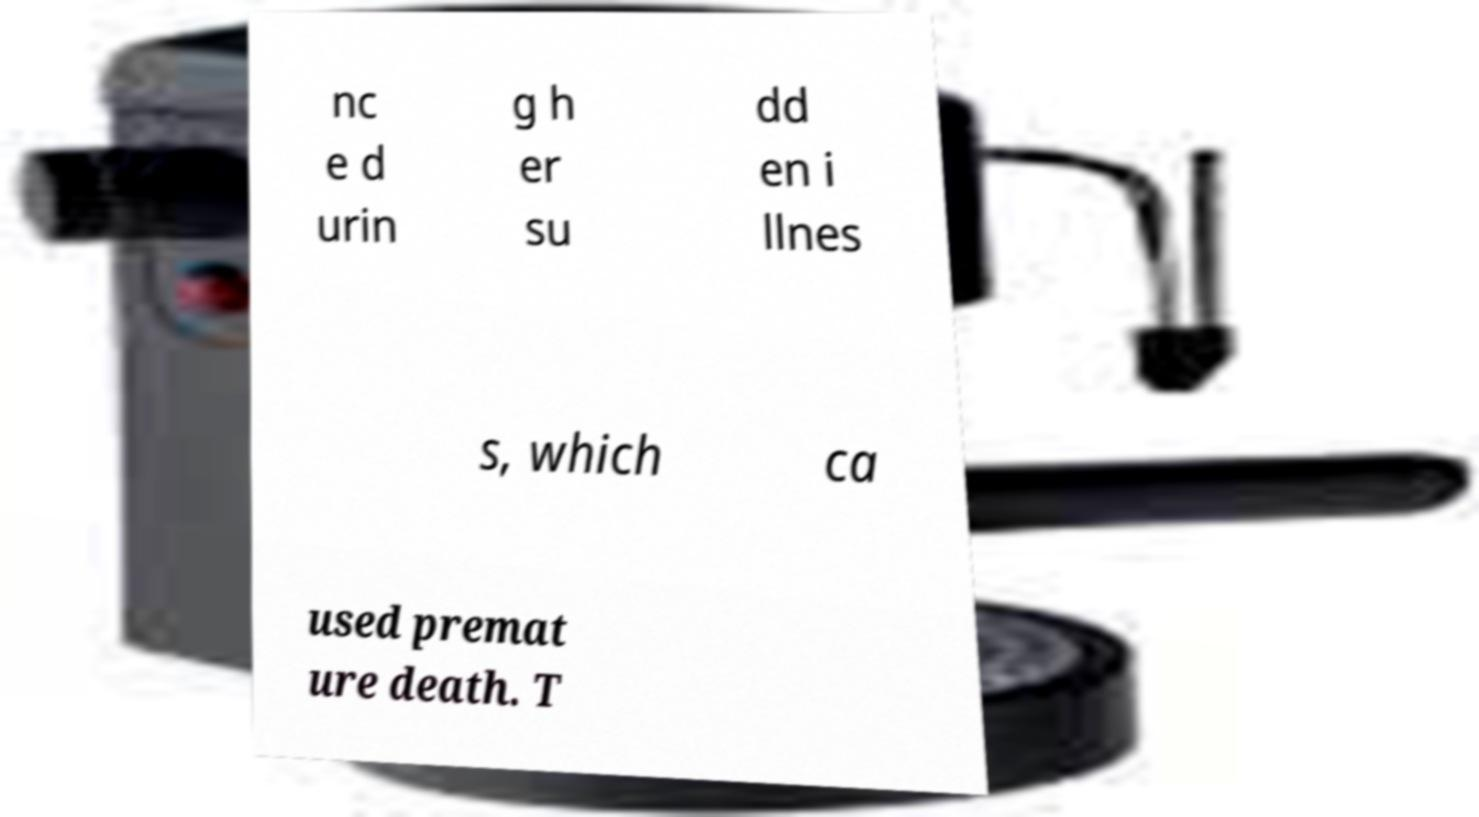Can you accurately transcribe the text from the provided image for me? nc e d urin g h er su dd en i llnes s, which ca used premat ure death. T 